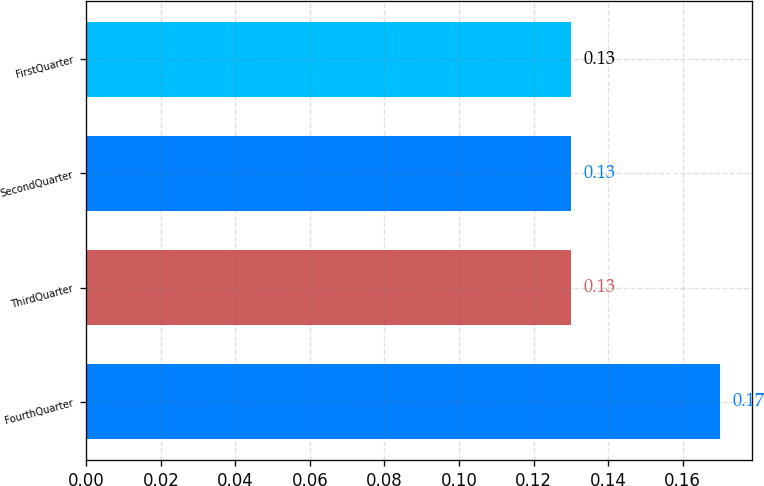Convert chart. <chart><loc_0><loc_0><loc_500><loc_500><bar_chart><fcel>FourthQuarter<fcel>ThirdQuarter<fcel>SecondQuarter<fcel>FirstQuarter<nl><fcel>0.17<fcel>0.13<fcel>0.13<fcel>0.13<nl></chart> 